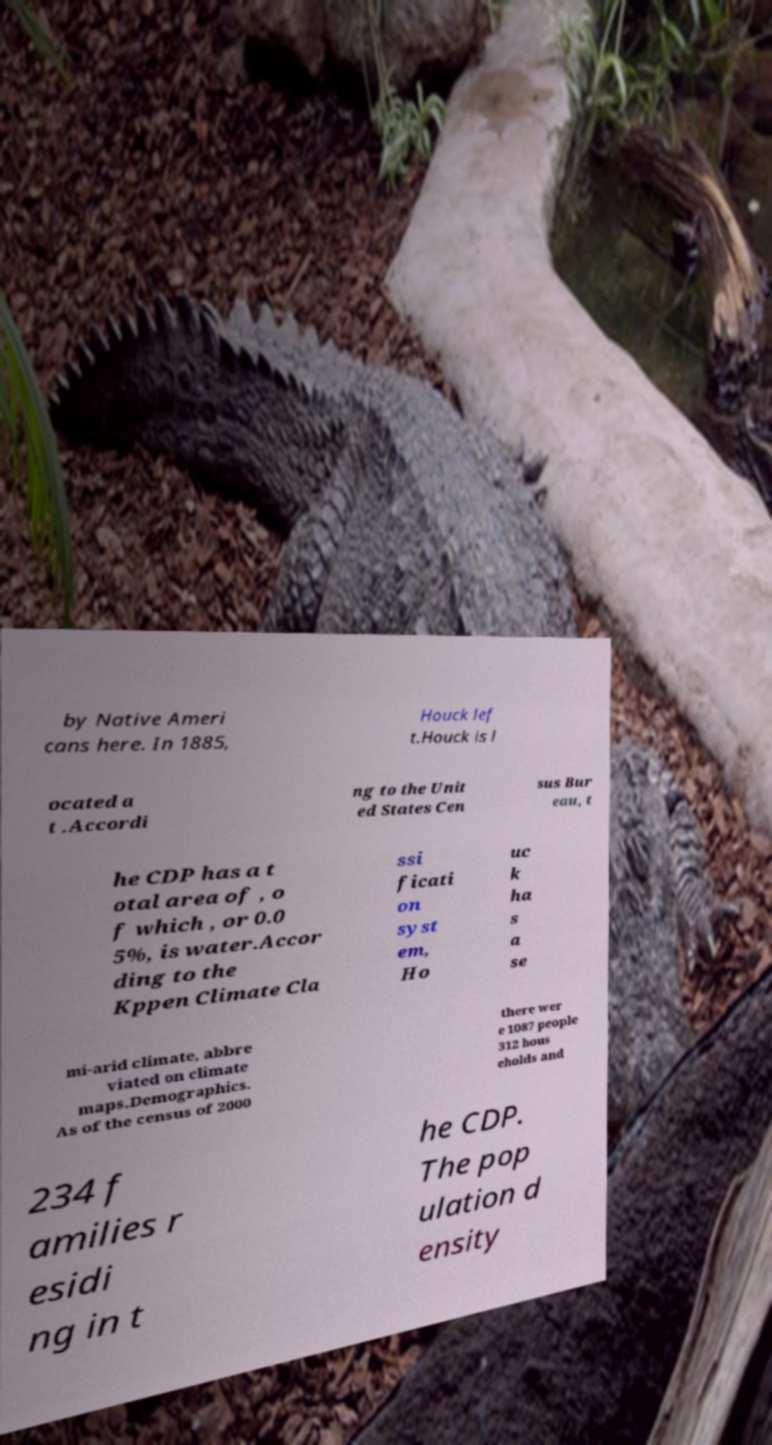Can you accurately transcribe the text from the provided image for me? by Native Ameri cans here. In 1885, Houck lef t.Houck is l ocated a t .Accordi ng to the Unit ed States Cen sus Bur eau, t he CDP has a t otal area of , o f which , or 0.0 5%, is water.Accor ding to the Kppen Climate Cla ssi ficati on syst em, Ho uc k ha s a se mi-arid climate, abbre viated on climate maps.Demographics. As of the census of 2000 there wer e 1087 people 312 hous eholds and 234 f amilies r esidi ng in t he CDP. The pop ulation d ensity 